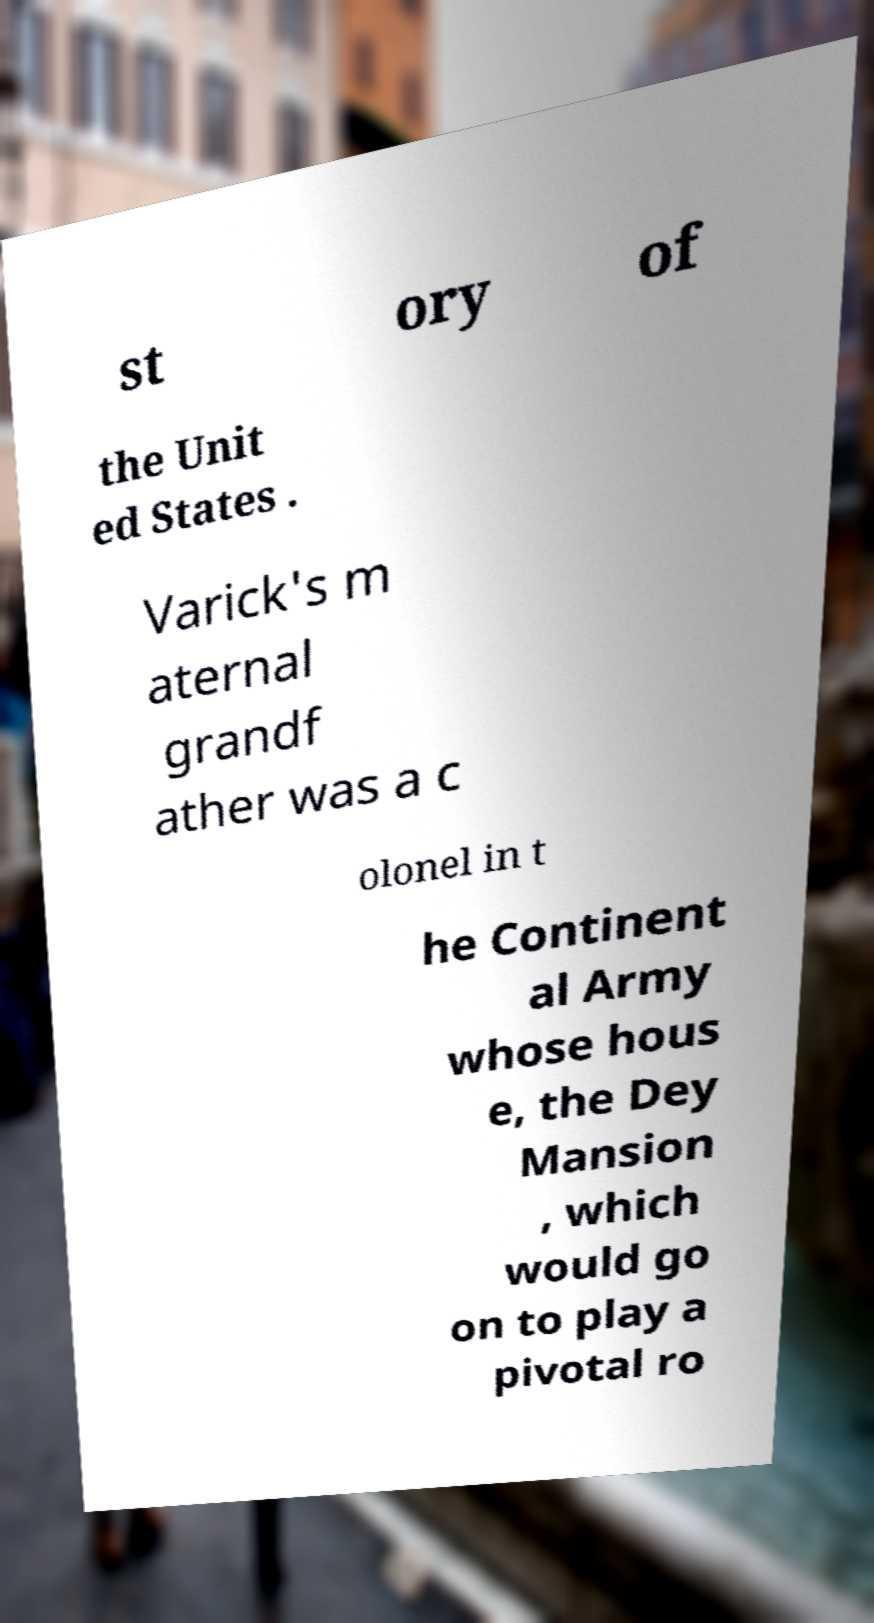There's text embedded in this image that I need extracted. Can you transcribe it verbatim? st ory of the Unit ed States . Varick's m aternal grandf ather was a c olonel in t he Continent al Army whose hous e, the Dey Mansion , which would go on to play a pivotal ro 